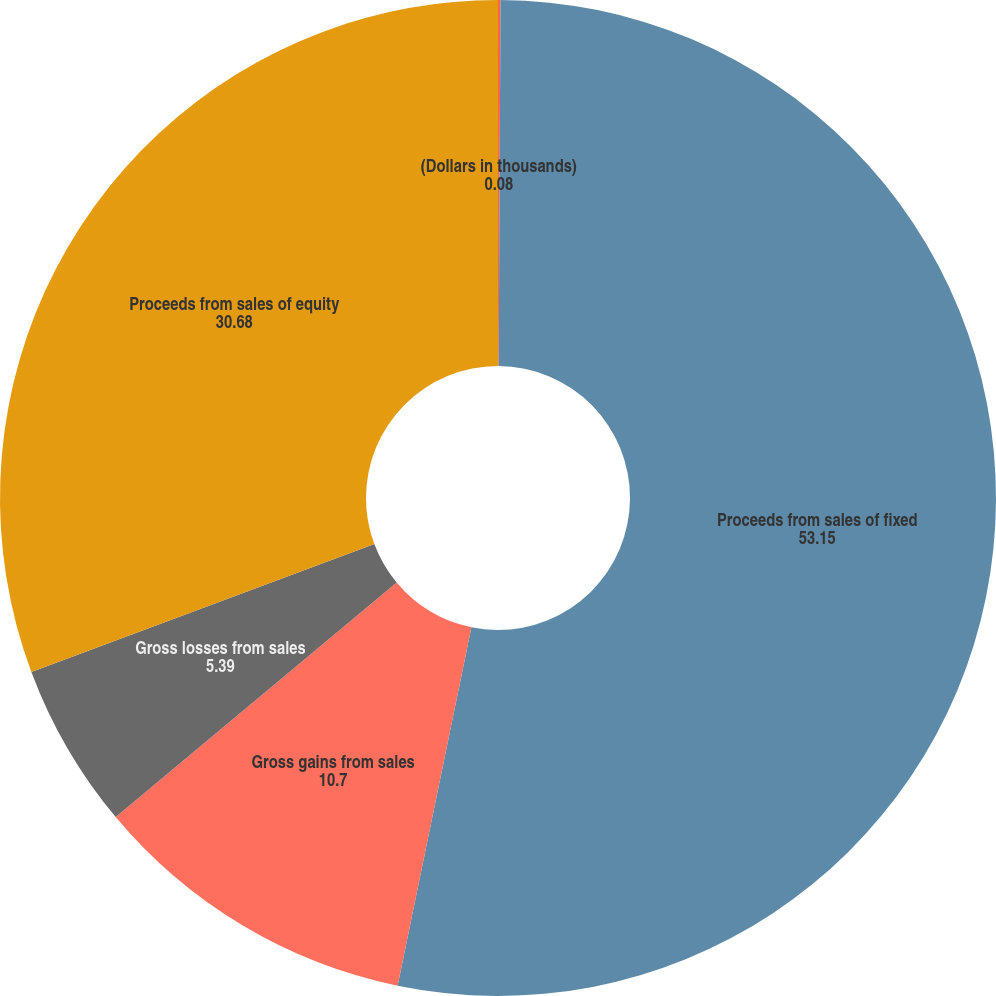Convert chart to OTSL. <chart><loc_0><loc_0><loc_500><loc_500><pie_chart><fcel>(Dollars in thousands)<fcel>Proceeds from sales of fixed<fcel>Gross gains from sales<fcel>Gross losses from sales<fcel>Proceeds from sales of equity<nl><fcel>0.08%<fcel>53.15%<fcel>10.7%<fcel>5.39%<fcel>30.68%<nl></chart> 